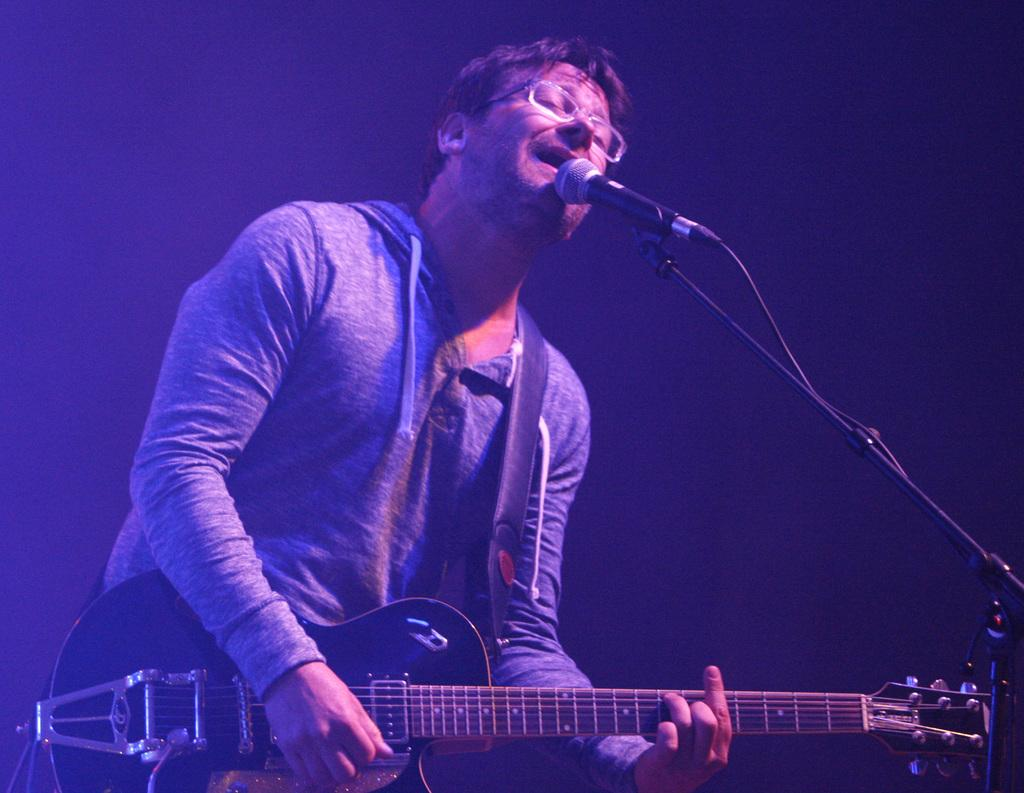What is the man in the image holding? The man is holding a guitar. What accessory is the man wearing in the image? The man is wearing specs. What object is present in the image that is commonly used for amplifying sound? There is a microphone in the image. What type of lamp is the governor using to read the wrist in the image? There is no lamp, governor, or wrist present in the image. 